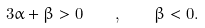Convert formula to latex. <formula><loc_0><loc_0><loc_500><loc_500>3 \alpha + \beta > 0 \quad , \quad \beta < 0 .</formula> 